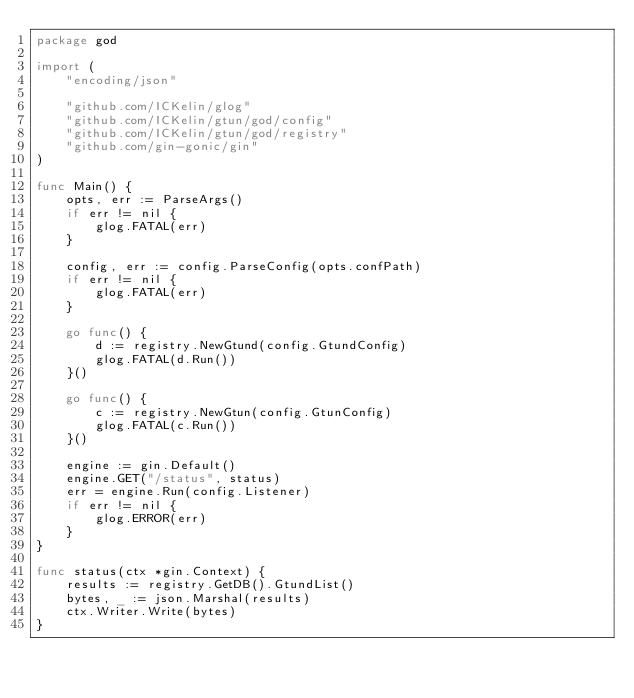<code> <loc_0><loc_0><loc_500><loc_500><_Go_>package god

import (
	"encoding/json"

	"github.com/ICKelin/glog"
	"github.com/ICKelin/gtun/god/config"
	"github.com/ICKelin/gtun/god/registry"
	"github.com/gin-gonic/gin"
)

func Main() {
	opts, err := ParseArgs()
	if err != nil {
		glog.FATAL(err)
	}

	config, err := config.ParseConfig(opts.confPath)
	if err != nil {
		glog.FATAL(err)
	}

	go func() {
		d := registry.NewGtund(config.GtundConfig)
		glog.FATAL(d.Run())
	}()

	go func() {
		c := registry.NewGtun(config.GtunConfig)
		glog.FATAL(c.Run())
	}()

	engine := gin.Default()
	engine.GET("/status", status)
	err = engine.Run(config.Listener)
	if err != nil {
		glog.ERROR(err)
	}
}

func status(ctx *gin.Context) {
	results := registry.GetDB().GtundList()
	bytes, _ := json.Marshal(results)
	ctx.Writer.Write(bytes)
}
</code> 